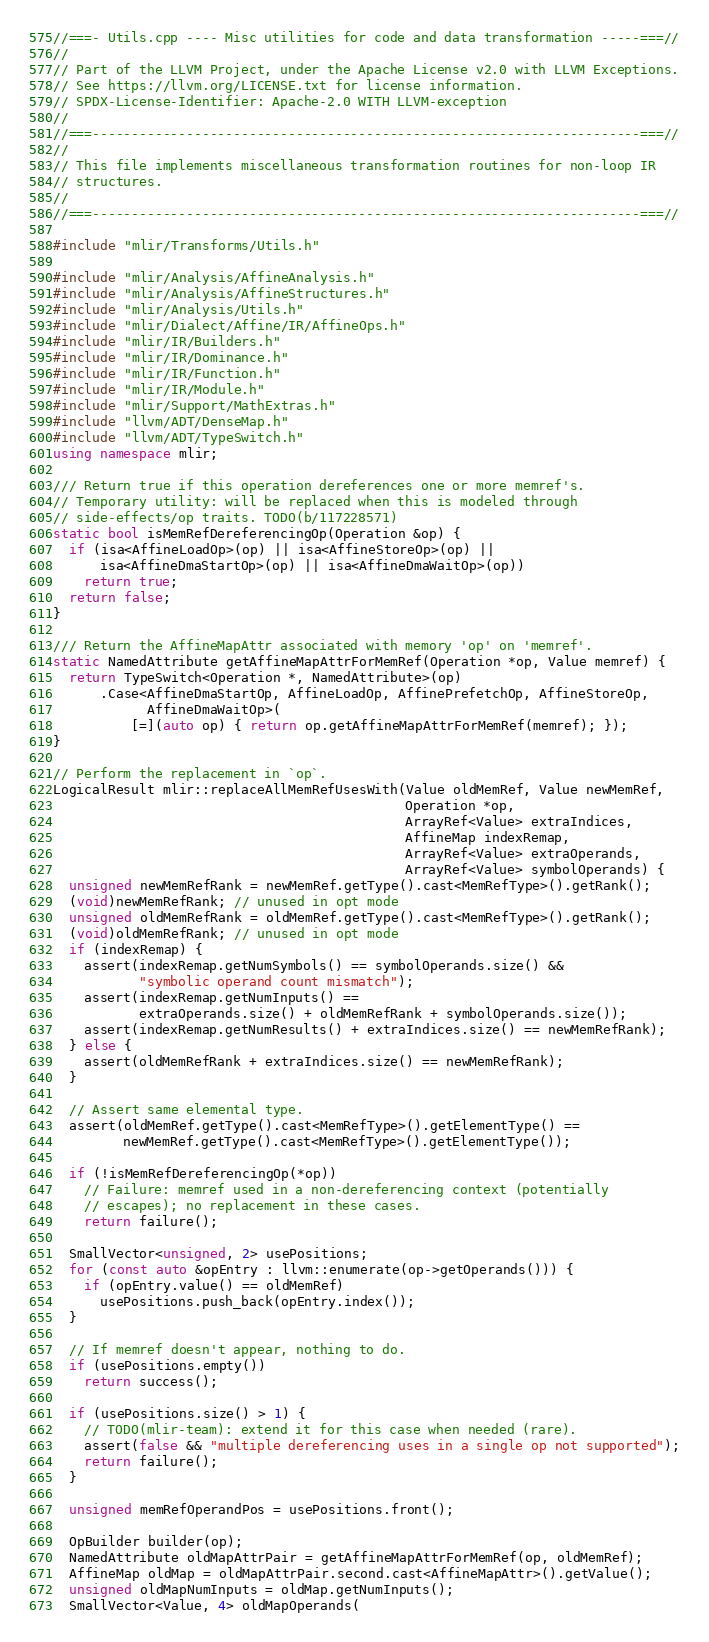<code> <loc_0><loc_0><loc_500><loc_500><_C++_>//===- Utils.cpp ---- Misc utilities for code and data transformation -----===//
//
// Part of the LLVM Project, under the Apache License v2.0 with LLVM Exceptions.
// See https://llvm.org/LICENSE.txt for license information.
// SPDX-License-Identifier: Apache-2.0 WITH LLVM-exception
//
//===----------------------------------------------------------------------===//
//
// This file implements miscellaneous transformation routines for non-loop IR
// structures.
//
//===----------------------------------------------------------------------===//

#include "mlir/Transforms/Utils.h"

#include "mlir/Analysis/AffineAnalysis.h"
#include "mlir/Analysis/AffineStructures.h"
#include "mlir/Analysis/Utils.h"
#include "mlir/Dialect/Affine/IR/AffineOps.h"
#include "mlir/IR/Builders.h"
#include "mlir/IR/Dominance.h"
#include "mlir/IR/Function.h"
#include "mlir/IR/Module.h"
#include "mlir/Support/MathExtras.h"
#include "llvm/ADT/DenseMap.h"
#include "llvm/ADT/TypeSwitch.h"
using namespace mlir;

/// Return true if this operation dereferences one or more memref's.
// Temporary utility: will be replaced when this is modeled through
// side-effects/op traits. TODO(b/117228571)
static bool isMemRefDereferencingOp(Operation &op) {
  if (isa<AffineLoadOp>(op) || isa<AffineStoreOp>(op) ||
      isa<AffineDmaStartOp>(op) || isa<AffineDmaWaitOp>(op))
    return true;
  return false;
}

/// Return the AffineMapAttr associated with memory 'op' on 'memref'.
static NamedAttribute getAffineMapAttrForMemRef(Operation *op, Value memref) {
  return TypeSwitch<Operation *, NamedAttribute>(op)
      .Case<AffineDmaStartOp, AffineLoadOp, AffinePrefetchOp, AffineStoreOp,
            AffineDmaWaitOp>(
          [=](auto op) { return op.getAffineMapAttrForMemRef(memref); });
}

// Perform the replacement in `op`.
LogicalResult mlir::replaceAllMemRefUsesWith(Value oldMemRef, Value newMemRef,
                                             Operation *op,
                                             ArrayRef<Value> extraIndices,
                                             AffineMap indexRemap,
                                             ArrayRef<Value> extraOperands,
                                             ArrayRef<Value> symbolOperands) {
  unsigned newMemRefRank = newMemRef.getType().cast<MemRefType>().getRank();
  (void)newMemRefRank; // unused in opt mode
  unsigned oldMemRefRank = oldMemRef.getType().cast<MemRefType>().getRank();
  (void)oldMemRefRank; // unused in opt mode
  if (indexRemap) {
    assert(indexRemap.getNumSymbols() == symbolOperands.size() &&
           "symbolic operand count mismatch");
    assert(indexRemap.getNumInputs() ==
           extraOperands.size() + oldMemRefRank + symbolOperands.size());
    assert(indexRemap.getNumResults() + extraIndices.size() == newMemRefRank);
  } else {
    assert(oldMemRefRank + extraIndices.size() == newMemRefRank);
  }

  // Assert same elemental type.
  assert(oldMemRef.getType().cast<MemRefType>().getElementType() ==
         newMemRef.getType().cast<MemRefType>().getElementType());

  if (!isMemRefDereferencingOp(*op))
    // Failure: memref used in a non-dereferencing context (potentially
    // escapes); no replacement in these cases.
    return failure();

  SmallVector<unsigned, 2> usePositions;
  for (const auto &opEntry : llvm::enumerate(op->getOperands())) {
    if (opEntry.value() == oldMemRef)
      usePositions.push_back(opEntry.index());
  }

  // If memref doesn't appear, nothing to do.
  if (usePositions.empty())
    return success();

  if (usePositions.size() > 1) {
    // TODO(mlir-team): extend it for this case when needed (rare).
    assert(false && "multiple dereferencing uses in a single op not supported");
    return failure();
  }

  unsigned memRefOperandPos = usePositions.front();

  OpBuilder builder(op);
  NamedAttribute oldMapAttrPair = getAffineMapAttrForMemRef(op, oldMemRef);
  AffineMap oldMap = oldMapAttrPair.second.cast<AffineMapAttr>().getValue();
  unsigned oldMapNumInputs = oldMap.getNumInputs();
  SmallVector<Value, 4> oldMapOperands(</code> 